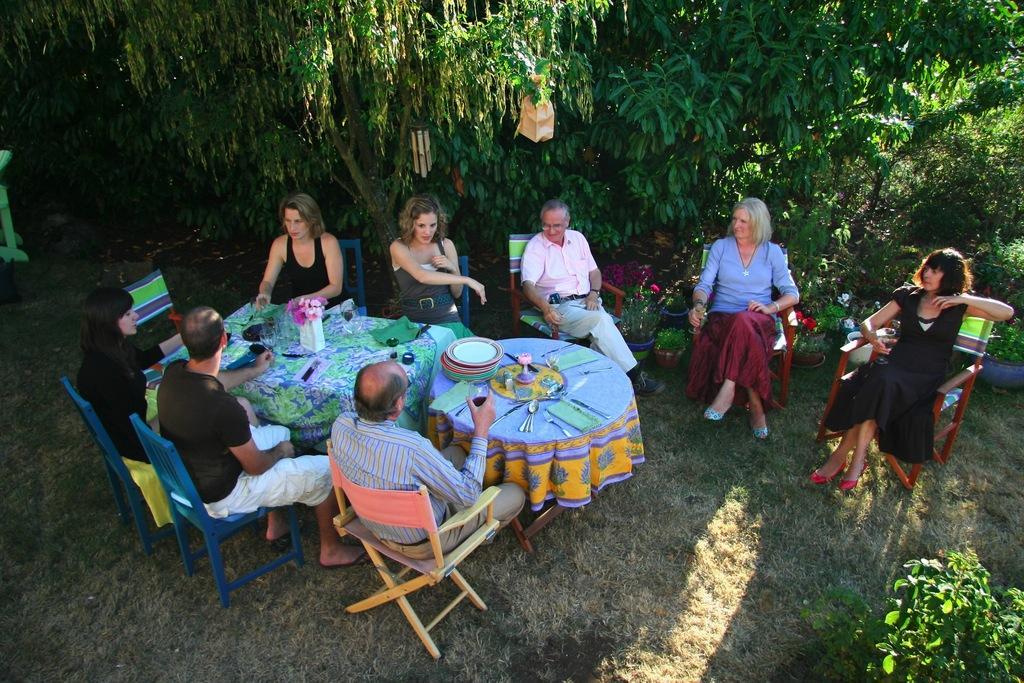Describe this image in one or two sentences. This picture shows a group of people seated on the chairs some plants and flowers on the table and we see some trees around. 